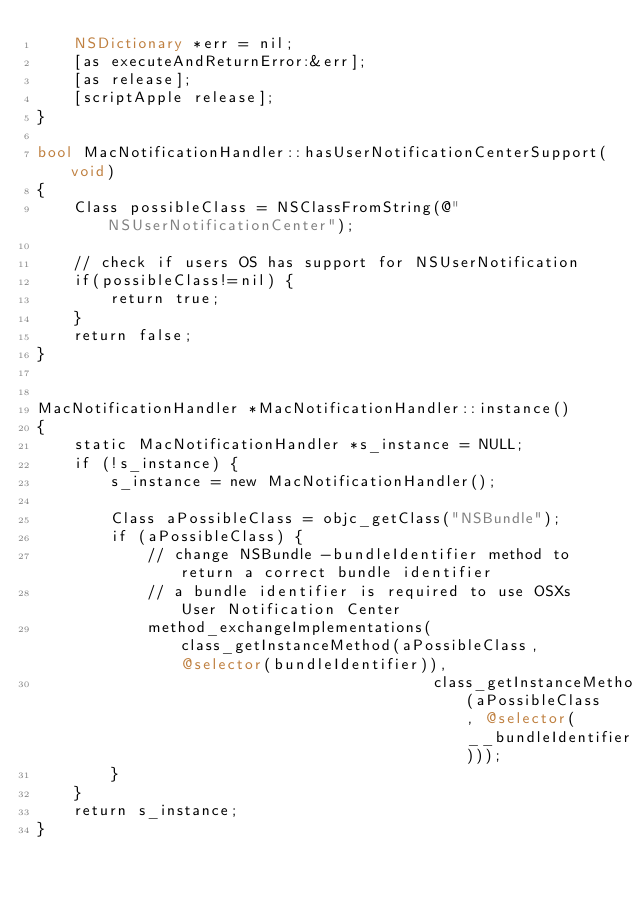<code> <loc_0><loc_0><loc_500><loc_500><_ObjectiveC_>    NSDictionary *err = nil;
    [as executeAndReturnError:&err];
    [as release];
    [scriptApple release];
}

bool MacNotificationHandler::hasUserNotificationCenterSupport(void)
{
    Class possibleClass = NSClassFromString(@"NSUserNotificationCenter");

    // check if users OS has support for NSUserNotification
    if(possibleClass!=nil) {
        return true;
    }
    return false;
}


MacNotificationHandler *MacNotificationHandler::instance()
{
    static MacNotificationHandler *s_instance = NULL;
    if (!s_instance) {
        s_instance = new MacNotificationHandler();
        
        Class aPossibleClass = objc_getClass("NSBundle");
        if (aPossibleClass) {
            // change NSBundle -bundleIdentifier method to return a correct bundle identifier
            // a bundle identifier is required to use OSXs User Notification Center
            method_exchangeImplementations(class_getInstanceMethod(aPossibleClass, @selector(bundleIdentifier)),
                                           class_getInstanceMethod(aPossibleClass, @selector(__bundleIdentifier)));
        }
    }
    return s_instance;
}
</code> 